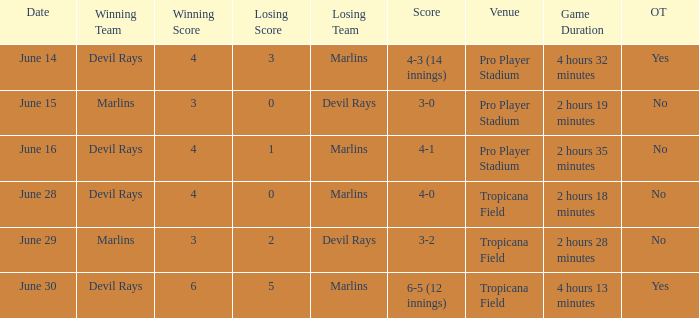What was the score on june 29 when the devil rays los? 3-2. 